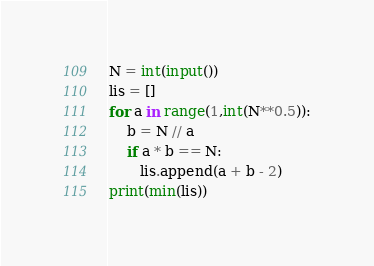Convert code to text. <code><loc_0><loc_0><loc_500><loc_500><_Python_>N = int(input())
lis = []
for a in range(1,int(N**0.5)):
    b = N // a
    if a * b == N:
       lis.append(a + b - 2)
print(min(lis)) </code> 